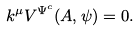<formula> <loc_0><loc_0><loc_500><loc_500>k ^ { \mu } V ^ { \Psi ^ { c } } ( A , \psi ) = 0 .</formula> 